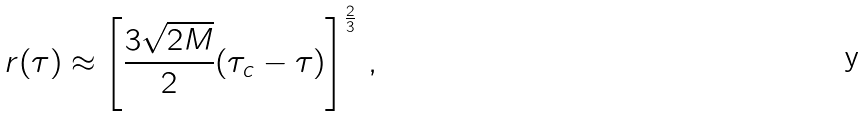<formula> <loc_0><loc_0><loc_500><loc_500>r ( \tau ) \approx \left [ \frac { 3 \sqrt { 2 M } } { 2 } ( \tau _ { c } - \tau ) \right ] ^ { \frac { 2 } { 3 } } \, ,</formula> 